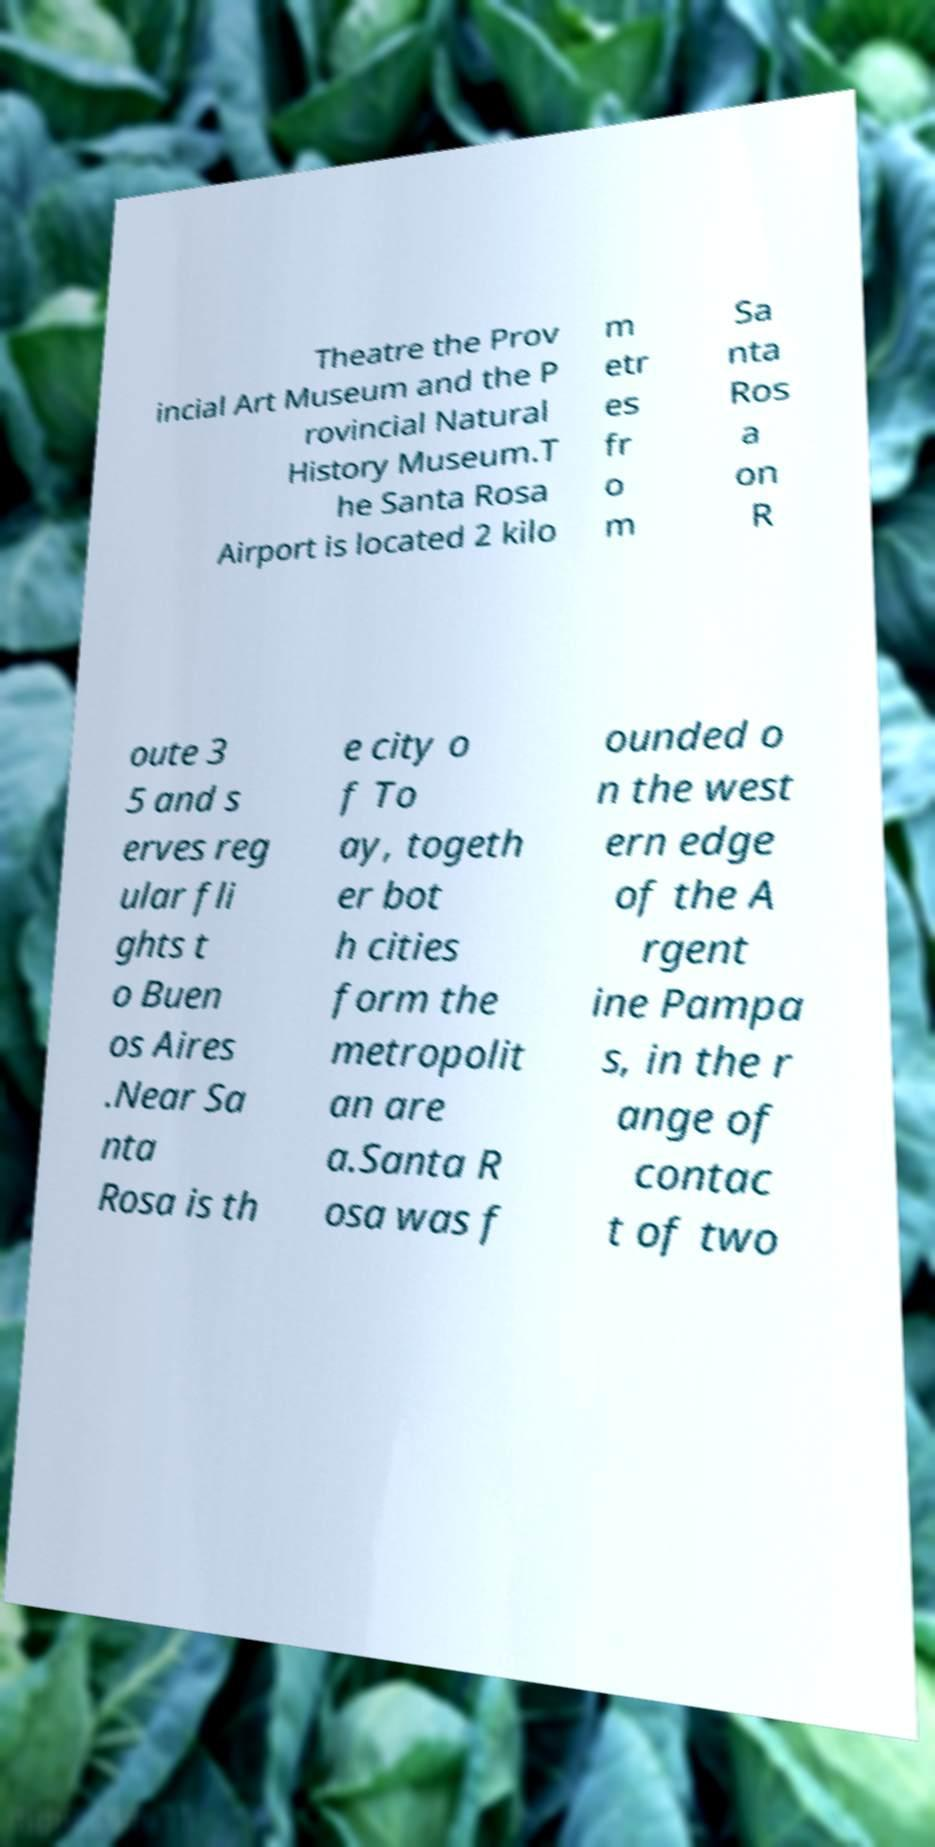I need the written content from this picture converted into text. Can you do that? Theatre the Prov incial Art Museum and the P rovincial Natural History Museum.T he Santa Rosa Airport is located 2 kilo m etr es fr o m Sa nta Ros a on R oute 3 5 and s erves reg ular fli ghts t o Buen os Aires .Near Sa nta Rosa is th e city o f To ay, togeth er bot h cities form the metropolit an are a.Santa R osa was f ounded o n the west ern edge of the A rgent ine Pampa s, in the r ange of contac t of two 